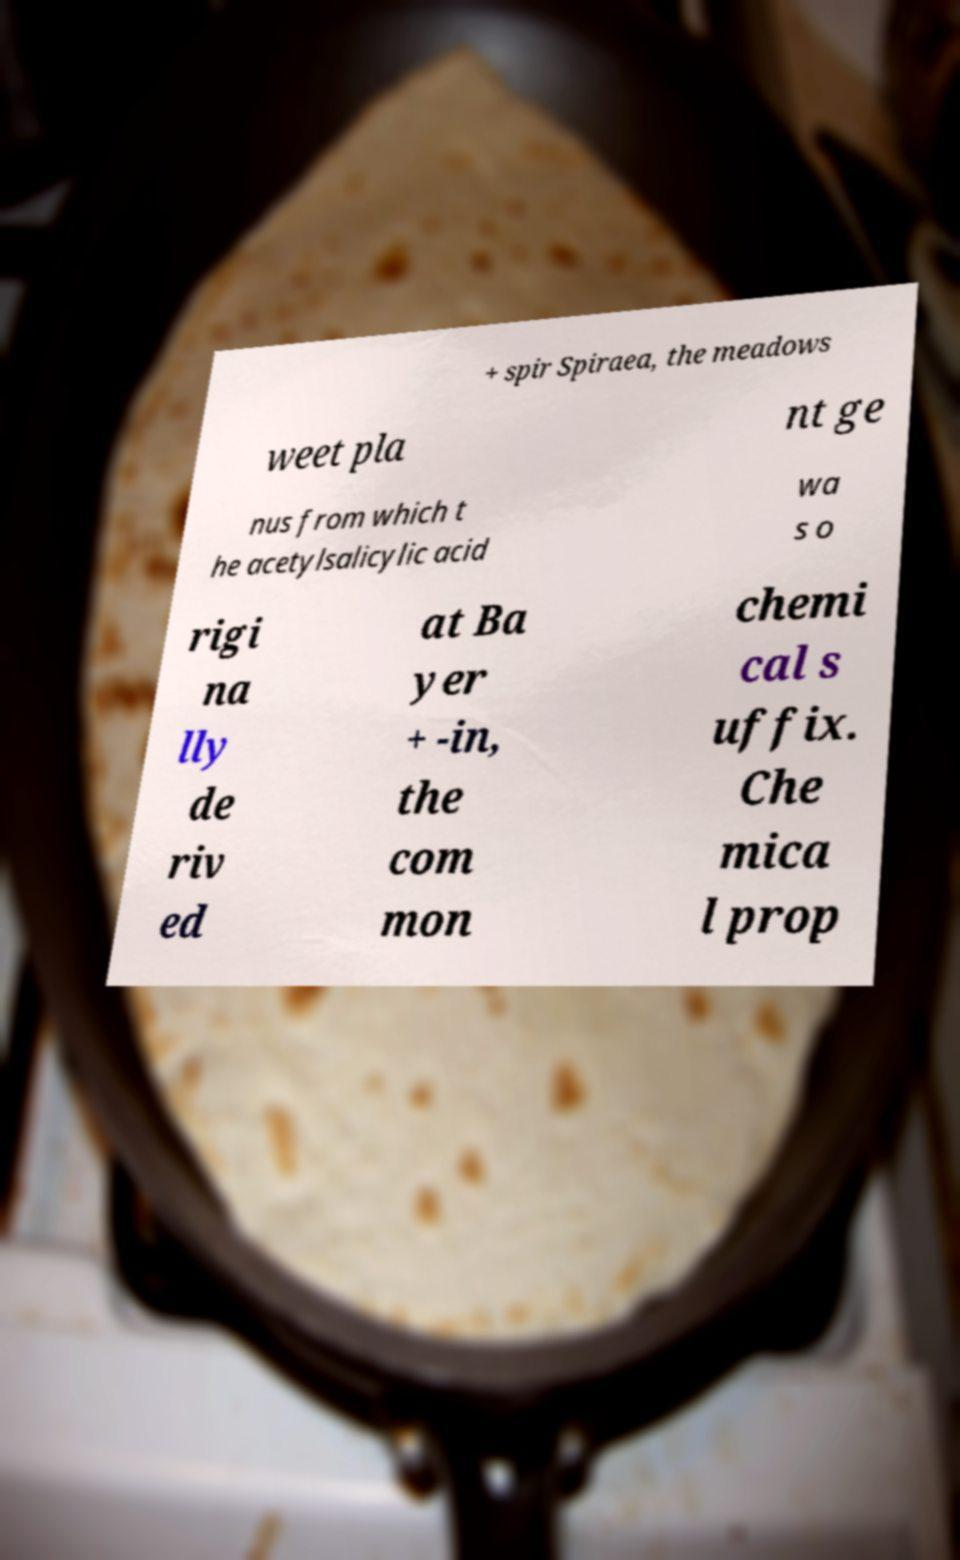I need the written content from this picture converted into text. Can you do that? + spir Spiraea, the meadows weet pla nt ge nus from which t he acetylsalicylic acid wa s o rigi na lly de riv ed at Ba yer + -in, the com mon chemi cal s uffix. Che mica l prop 